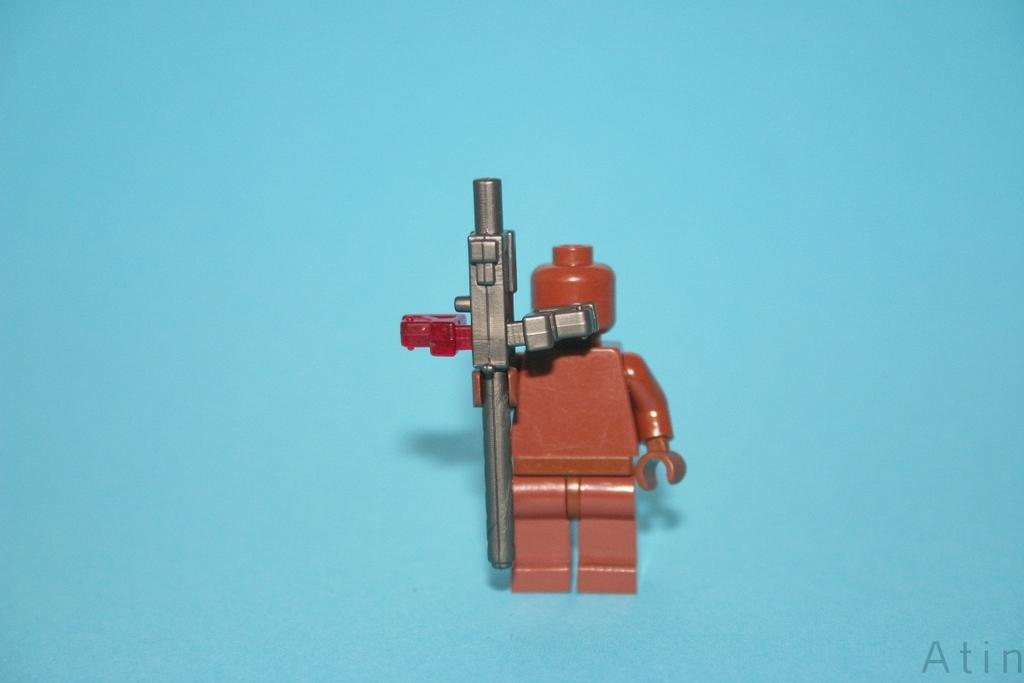What is the color of the toy in the image? The toy in the image is brown. What color is the background of the image? The background of the image is blue. Where is the watermark located in the image? The watermark is at the bottom right side of the image. What is the chance of the toy flying in the image? The toy does not fly in the image, as it is a stationary object. 